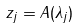<formula> <loc_0><loc_0><loc_500><loc_500>z _ { j } = A ( \lambda _ { j } )</formula> 